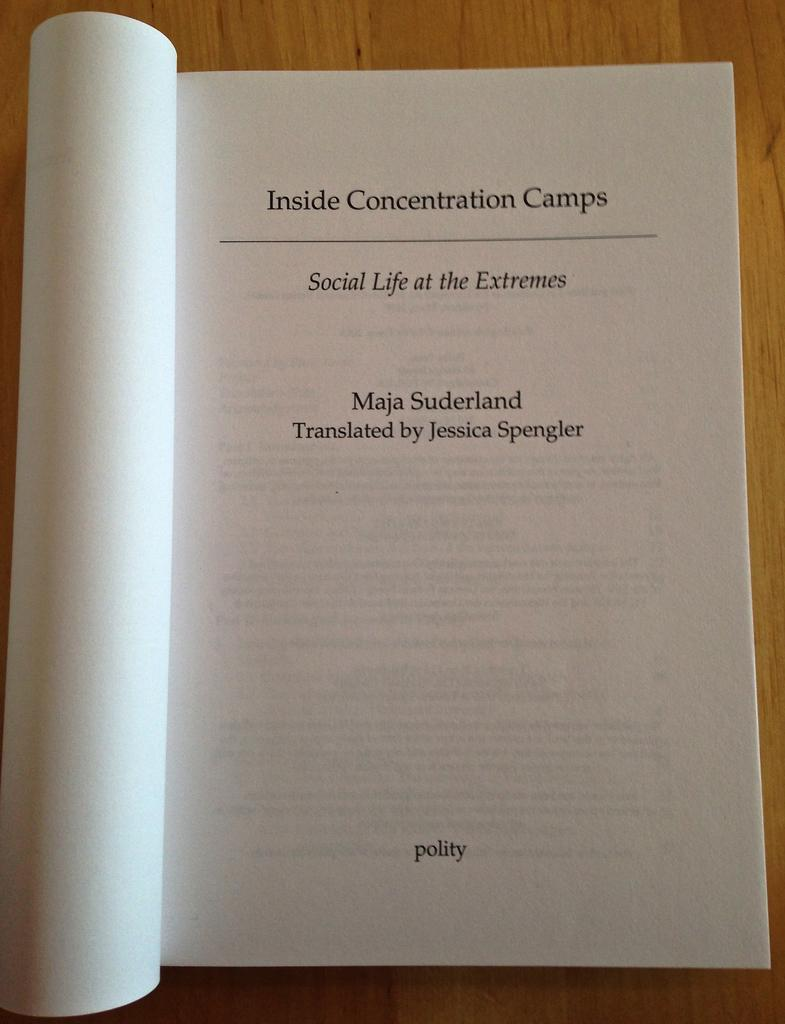Provide a one-sentence caption for the provided image. A book opened to a page with Inside Concentration Camps at the top of the page. 